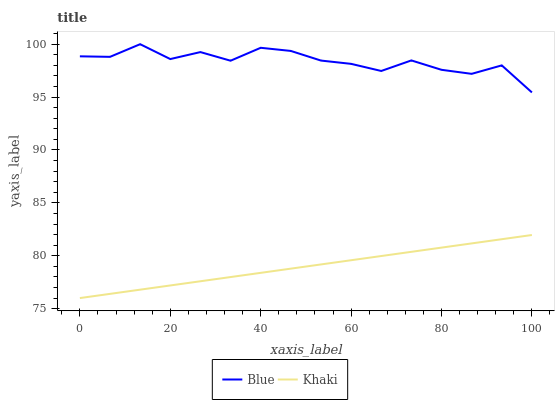Does Khaki have the maximum area under the curve?
Answer yes or no. No. Is Khaki the roughest?
Answer yes or no. No. Does Khaki have the highest value?
Answer yes or no. No. Is Khaki less than Blue?
Answer yes or no. Yes. Is Blue greater than Khaki?
Answer yes or no. Yes. Does Khaki intersect Blue?
Answer yes or no. No. 